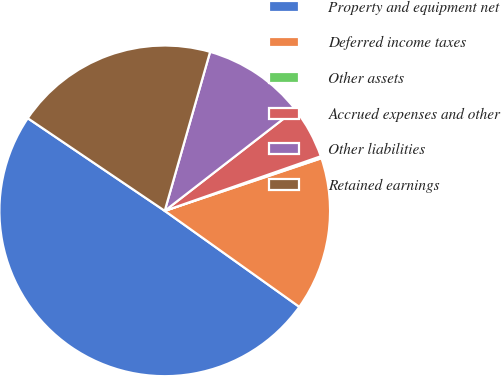Convert chart. <chart><loc_0><loc_0><loc_500><loc_500><pie_chart><fcel>Property and equipment net<fcel>Deferred income taxes<fcel>Other assets<fcel>Accrued expenses and other<fcel>Other liabilities<fcel>Retained earnings<nl><fcel>49.6%<fcel>15.02%<fcel>0.2%<fcel>5.14%<fcel>10.08%<fcel>19.96%<nl></chart> 